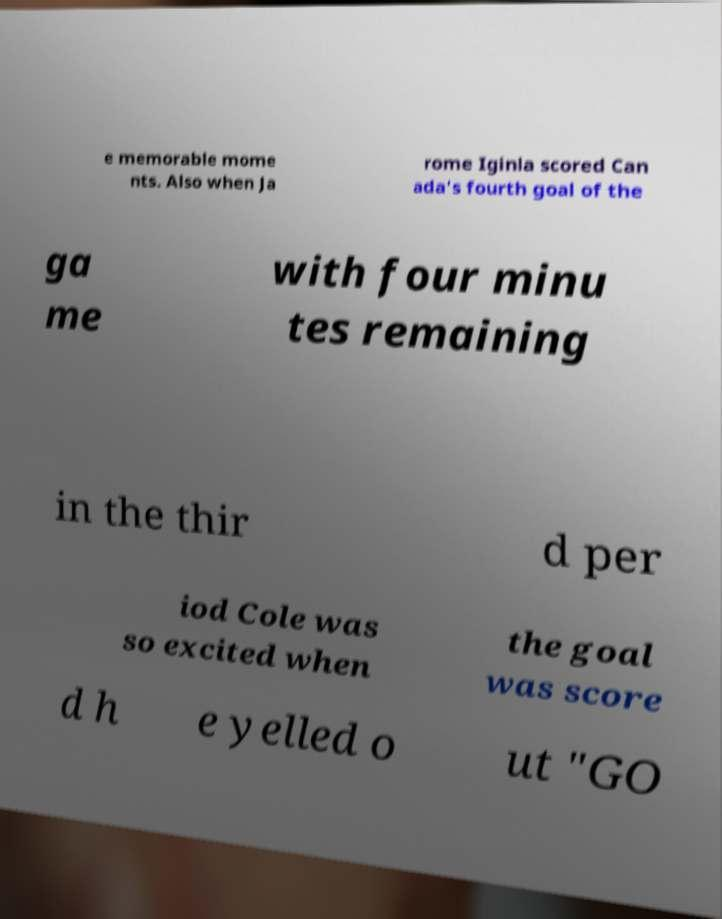What messages or text are displayed in this image? I need them in a readable, typed format. e memorable mome nts. Also when Ja rome Iginla scored Can ada's fourth goal of the ga me with four minu tes remaining in the thir d per iod Cole was so excited when the goal was score d h e yelled o ut "GO 